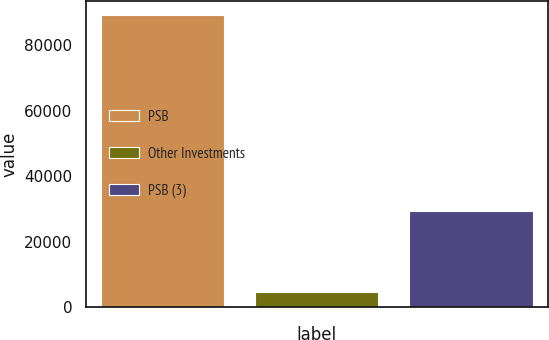Convert chart to OTSL. <chart><loc_0><loc_0><loc_500><loc_500><bar_chart><fcel>PSB<fcel>Other Investments<fcel>PSB (3)<nl><fcel>89067<fcel>4626<fcel>29320<nl></chart> 